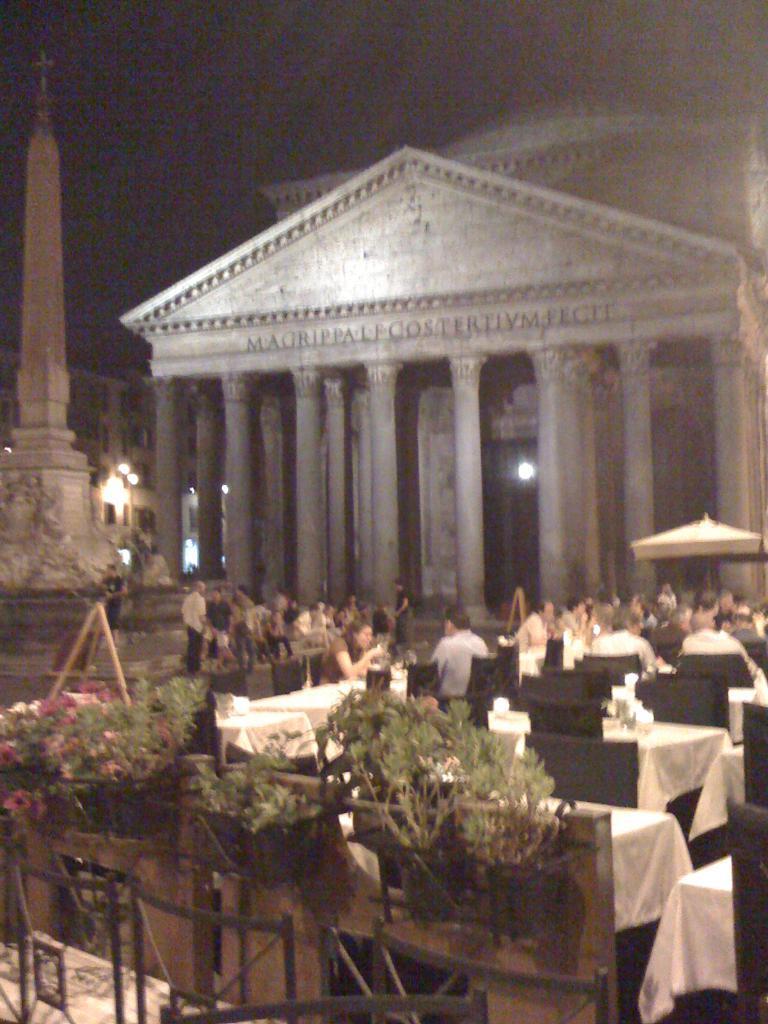Describe this image in one or two sentences. On the left side, there are potted plants arranged. In the background, there are chairs and tables arranged, on some of the cars, there are persons sitting, there are persons standing, there is a tower, there are buildings and there are lights. And the background is dark in color. 